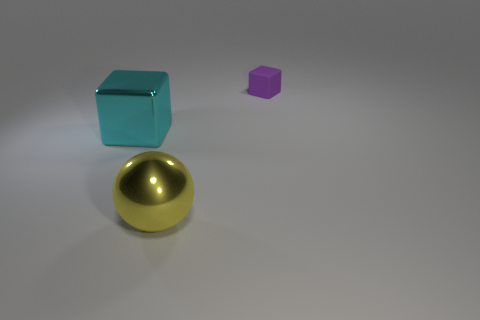Add 3 big cubes. How many objects exist? 6 Subtract all spheres. How many objects are left? 2 Subtract all cyan shiny cubes. Subtract all purple things. How many objects are left? 1 Add 3 metal blocks. How many metal blocks are left? 4 Add 2 red matte cubes. How many red matte cubes exist? 2 Subtract 0 brown spheres. How many objects are left? 3 